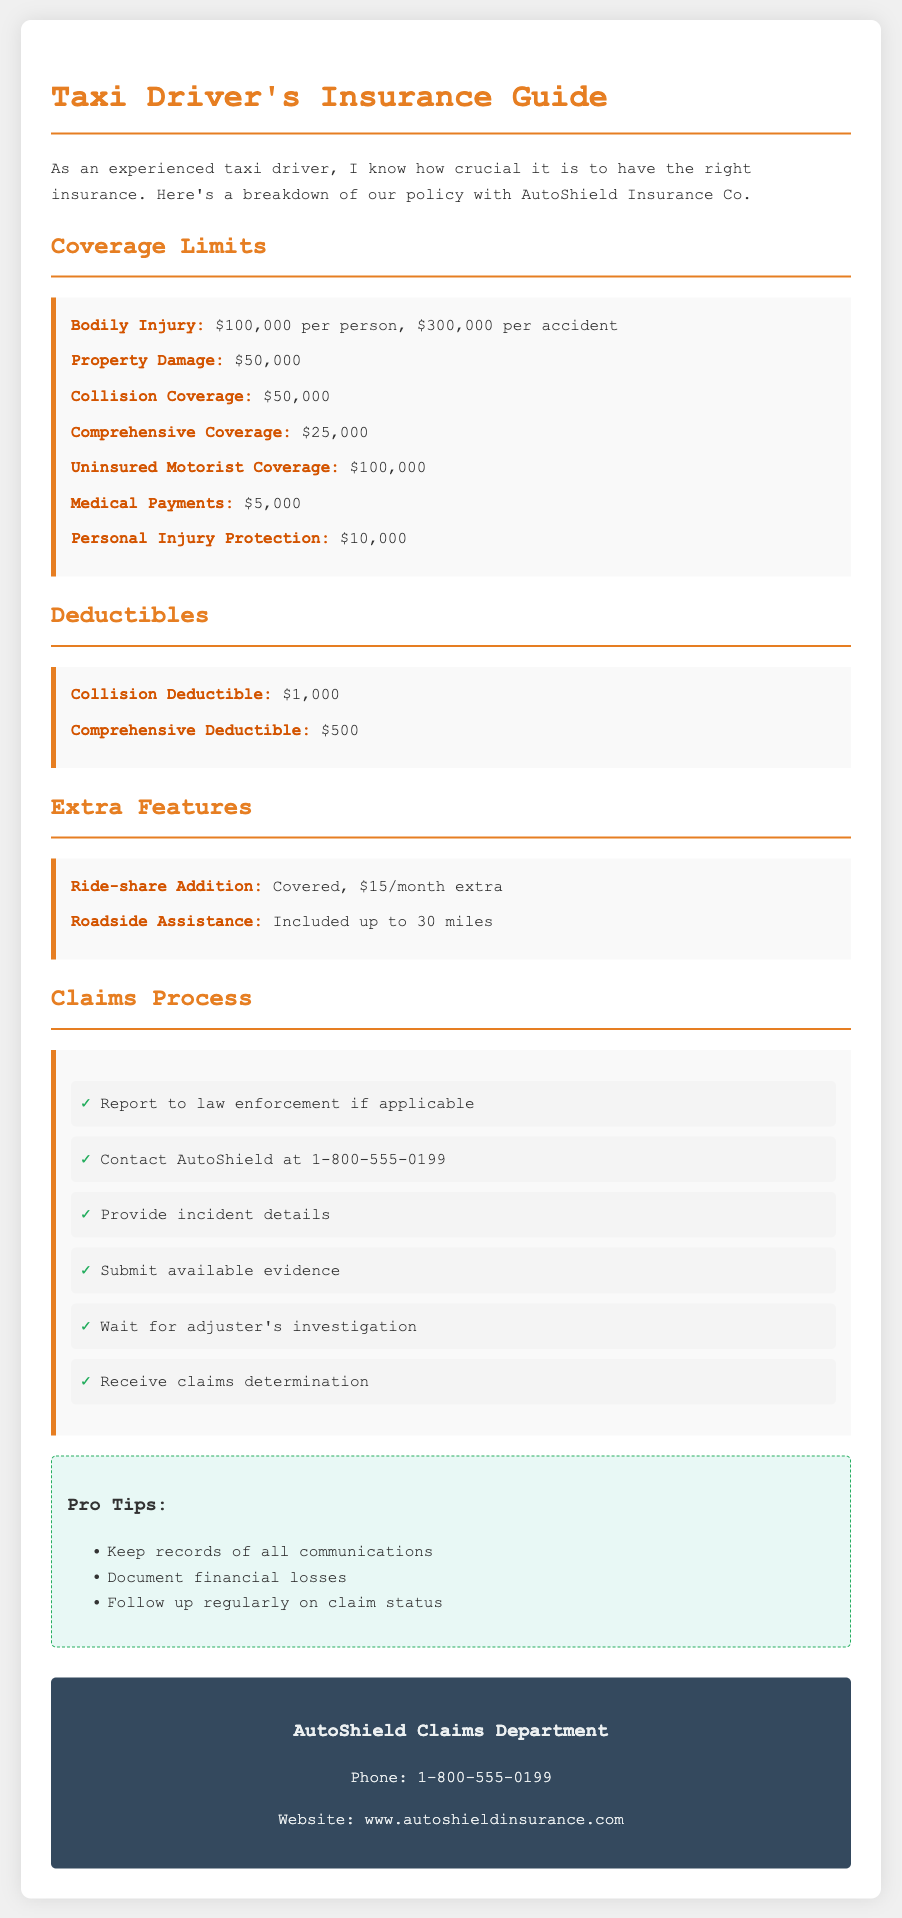What is the maximum coverage for Bodily Injury? The maximum coverage for Bodily Injury stated in the document is $100,000 per person, $300,000 per accident.
Answer: $100,000 per person, $300,000 per accident What is the Collision Deductible? The document specifically mentions the Collision Deductible amount.
Answer: $1,000 How much does the Ride-share Addition cost per month? The document specifies the monthly cost for adding ride-share coverage.
Answer: $15/month What is included in the Roadside Assistance feature? The document indicates the limit for Roadside Assistance provided in the insurance policy.
Answer: Included up to 30 miles What is the first step in the claims process? The document outlines steps for the claims process, with the first step being specified.
Answer: Report to law enforcement if applicable What is the total coverage limit for Property Damage? The coverage limit for Property Damage is mentioned specifically in the document.
Answer: $50,000 How many steps are there in the claims process? The claims process is outlined in a list, and the total number of steps is indicated.
Answer: 6 What kind of coverage does the Medical Payments provide? The document lists the specific limit for Medical Payments coverage.
Answer: $5,000 What organization provides the insurance policy? The document states the name of the insurance company providing the policy.
Answer: AutoShield Insurance Co 